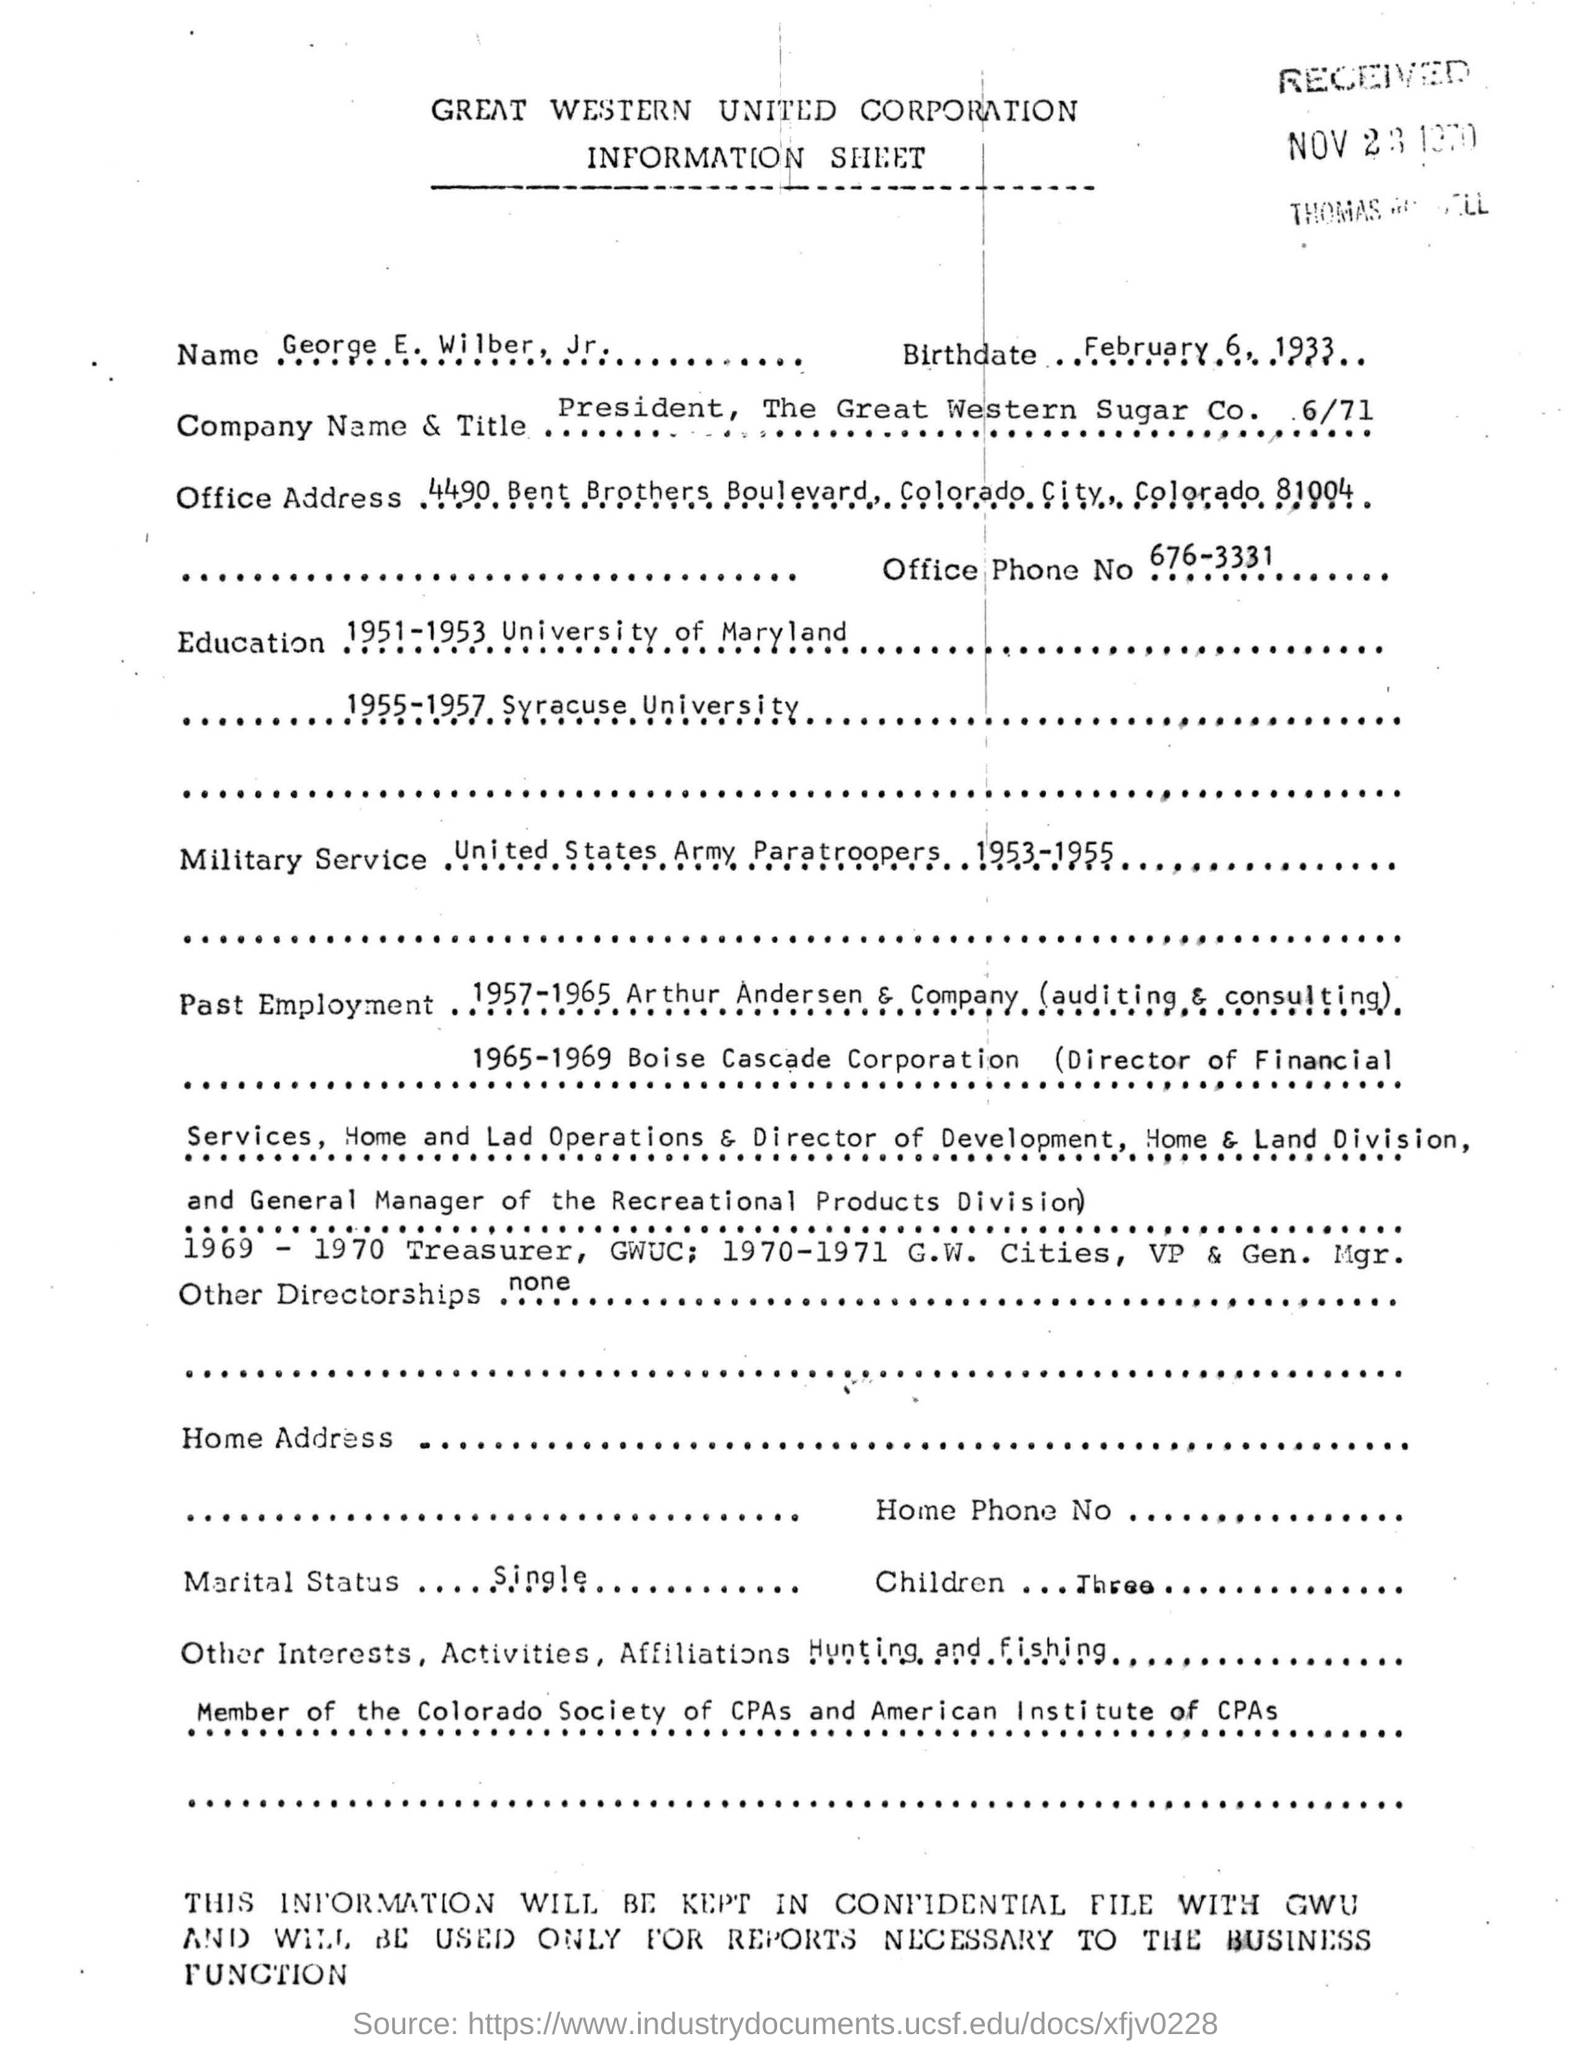Who is the the President of The Great Western Sugar Corporation?
Make the answer very short. George E Wilber Jr . What is the birthdate of George E Wilber Jr .?
Give a very brief answer. February 6, 1933. What is the Office Phone No given?
Ensure brevity in your answer.  676-3331. Mention the Military Service in which George E Wilber Jr . has worked.
Your response must be concise. United States Army Paratroopers. What is the Marital Status of George E Wilber Jr . ?
Give a very brief answer. Single. 